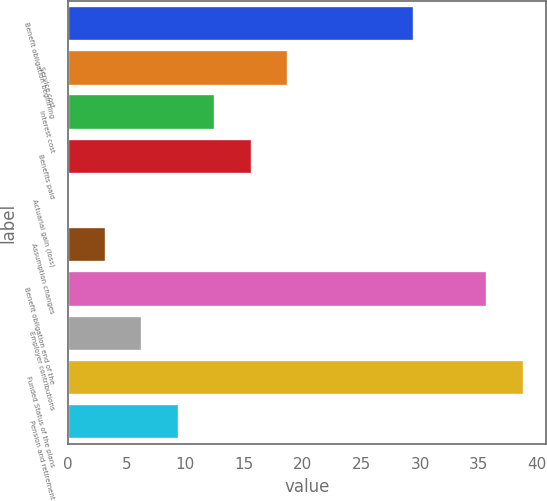Convert chart to OTSL. <chart><loc_0><loc_0><loc_500><loc_500><bar_chart><fcel>Benefit obligation beginning<fcel>Service cost<fcel>Interest cost<fcel>Benefits paid<fcel>Actuarial gain (loss)<fcel>Assumption changes<fcel>Benefit obligation end of the<fcel>Employer contributions<fcel>Funded Status of the plans<fcel>Pension and retirement<nl><fcel>29.5<fcel>18.76<fcel>12.54<fcel>15.65<fcel>0.1<fcel>3.21<fcel>35.72<fcel>6.32<fcel>38.83<fcel>9.43<nl></chart> 